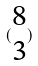Convert formula to latex. <formula><loc_0><loc_0><loc_500><loc_500>( \begin{matrix} 8 \\ 3 \end{matrix} )</formula> 